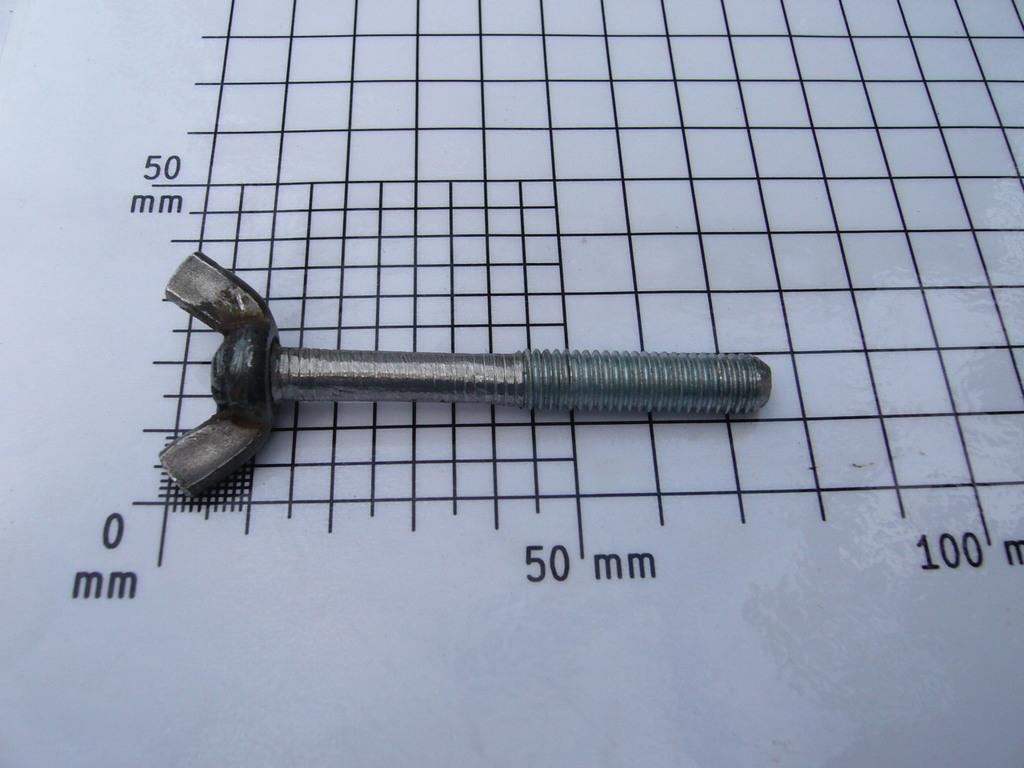<image>
Provide a brief description of the given image. A wing nut lies on top of a measuring grid that has marks for 0, 50, and 100 millimeters. 